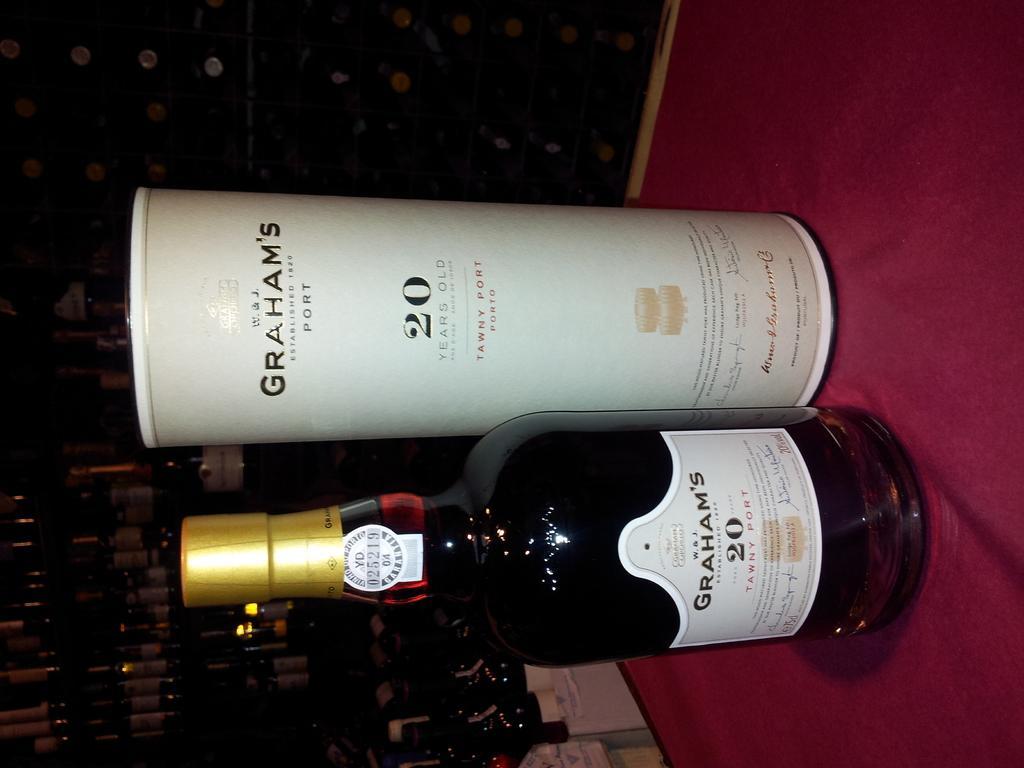How would you summarize this image in a sentence or two? In the middle of the image there is a wine bottle on the table. Left side of the image a few wine bottles are there. 